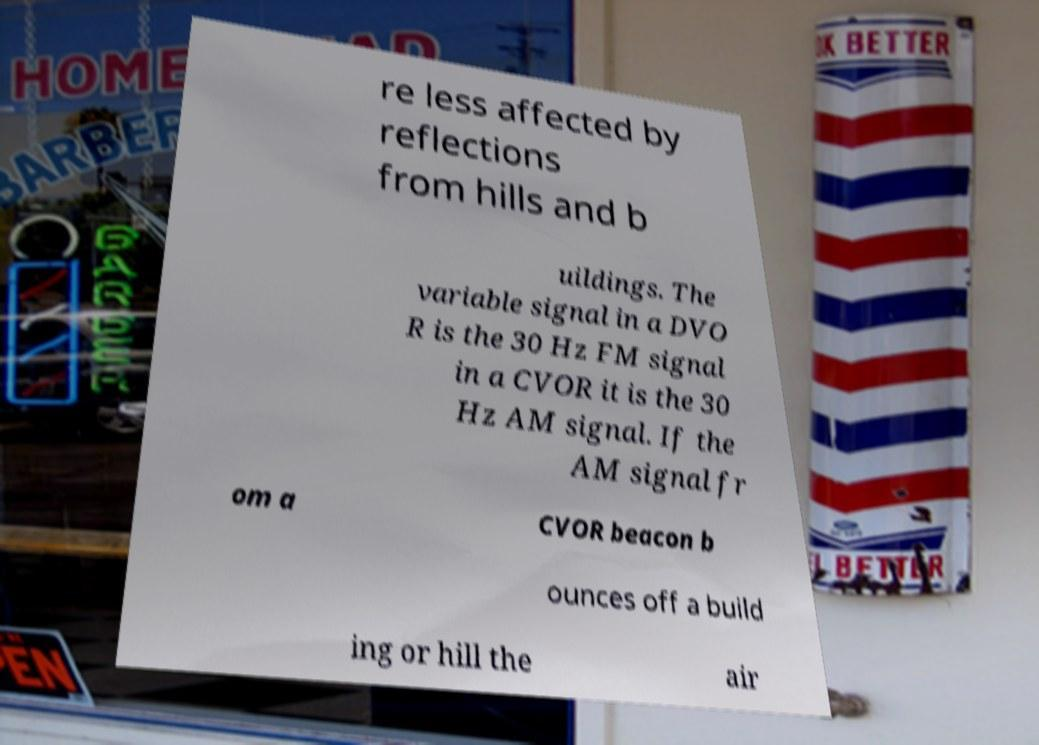Please read and relay the text visible in this image. What does it say? re less affected by reflections from hills and b uildings. The variable signal in a DVO R is the 30 Hz FM signal in a CVOR it is the 30 Hz AM signal. If the AM signal fr om a CVOR beacon b ounces off a build ing or hill the air 